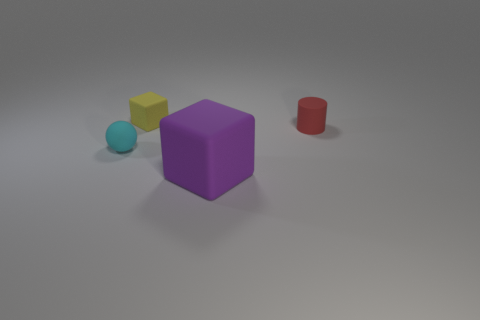Is there anything else that is the same size as the purple object?
Provide a succinct answer. No. Do the large purple thing and the thing behind the matte cylinder have the same shape?
Provide a succinct answer. Yes. What is the size of the matte object that is both in front of the small cylinder and right of the cyan matte ball?
Offer a terse response. Large. There is a tiny object that is left of the red rubber cylinder and to the right of the tiny cyan sphere; what is its color?
Offer a very short reply. Yellow. Are there fewer red things in front of the small rubber ball than purple matte cubes in front of the tiny yellow thing?
Offer a very short reply. Yes. There is a yellow thing; what shape is it?
Give a very brief answer. Cube. The cylinder that is made of the same material as the sphere is what color?
Keep it short and to the point. Red. Are there more yellow objects than brown cylinders?
Give a very brief answer. Yes. Are there any cyan shiny spheres?
Give a very brief answer. No. What shape is the matte thing that is right of the block in front of the small matte cylinder?
Provide a short and direct response. Cylinder. 